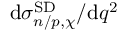<formula> <loc_0><loc_0><loc_500><loc_500>d \sigma _ { n / p , \chi } ^ { S D } / d q ^ { 2 }</formula> 